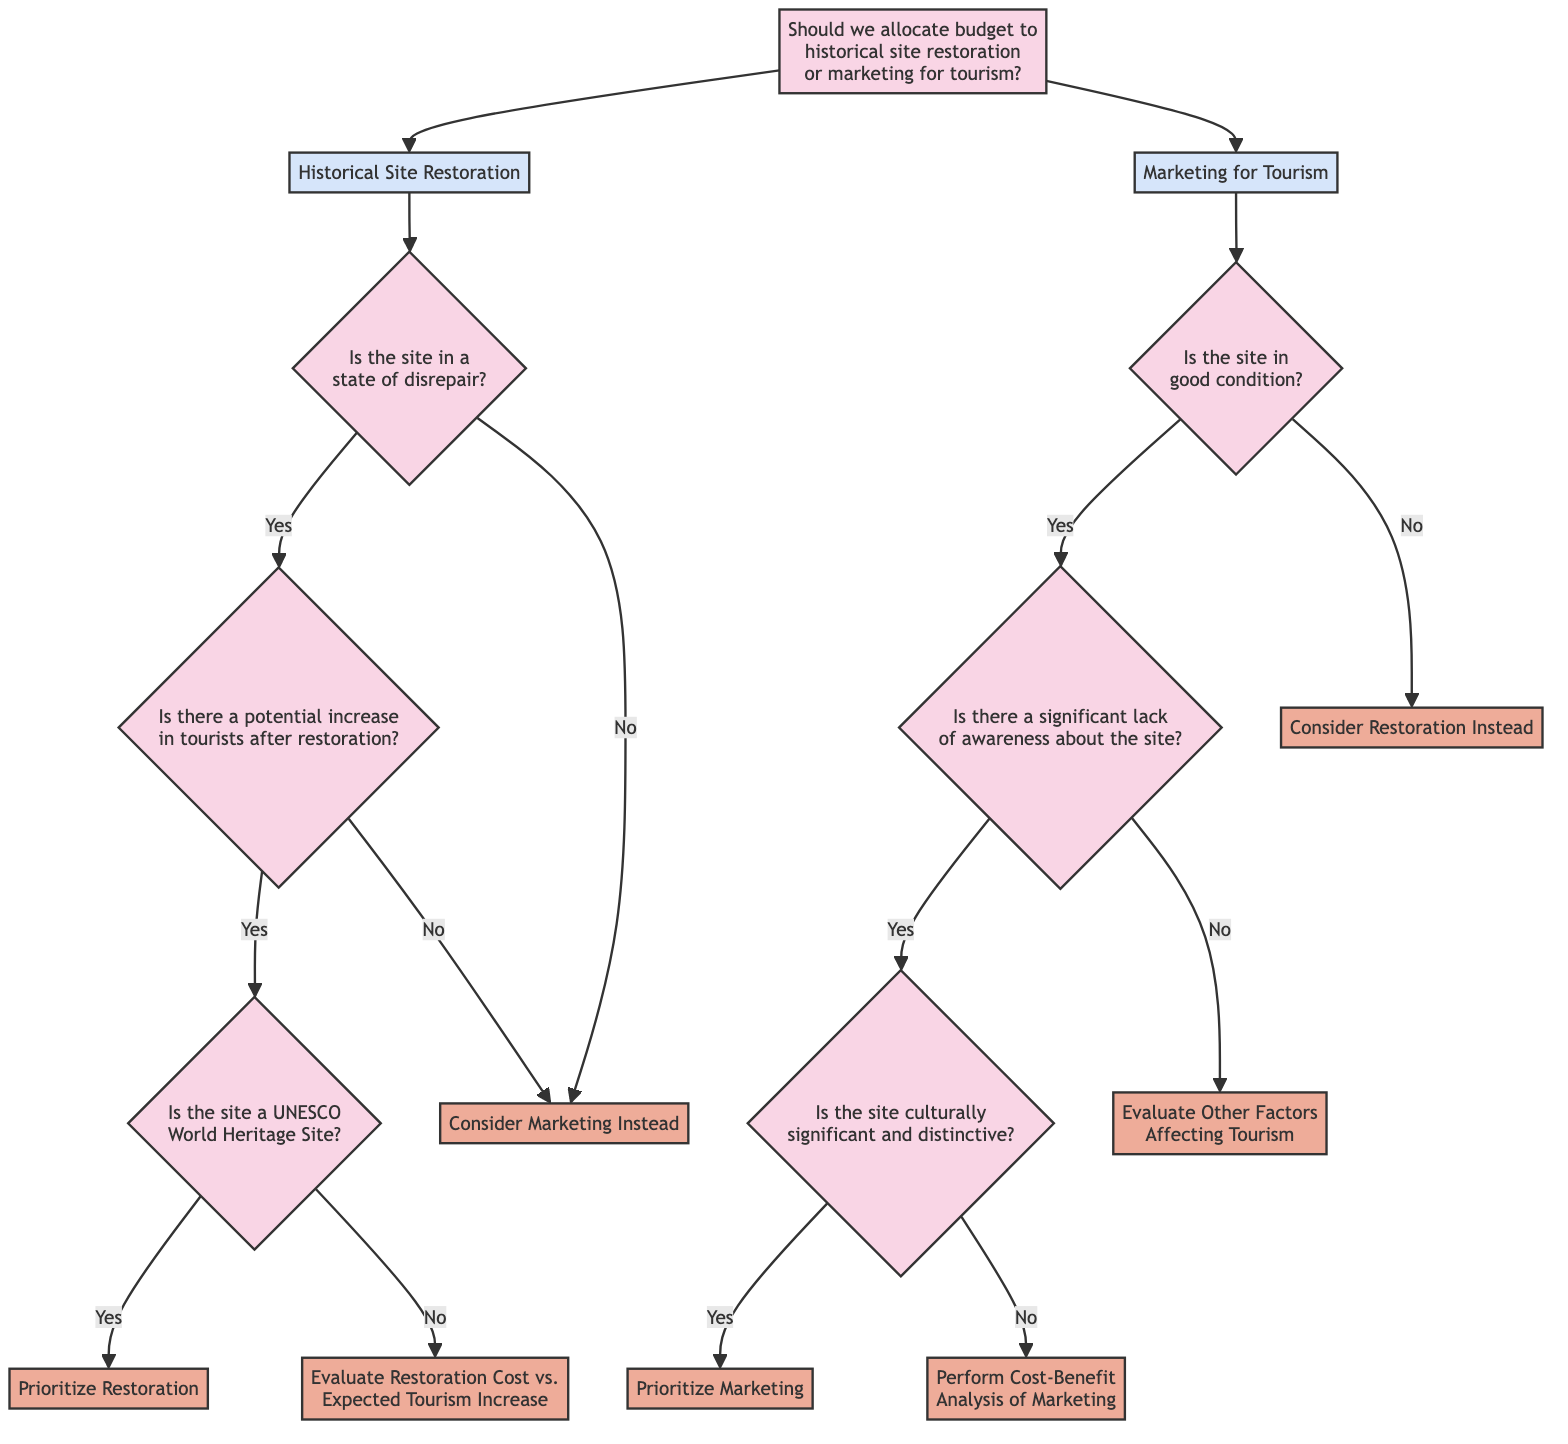What is the first decision to be made according to the diagram? The first decision presented in the diagram is whether to allocate budget to historical site restoration or marketing for tourism. This is the initial question represented at the top node of the decision tree.
Answer: historical site restoration or marketing for tourism How many options are available under historical site restoration? There are two main options under historical site restoration after deciding it: whether the site is in a state of disrepair (Yes or No). This branching shows two possible paths depending on the condition of the site.
Answer: 2 What action is prompted if the site is a UNESCO World Heritage Site? If the site is identified as a UNESCO World Heritage Site after determining that restoration would lead to increased tourism, the action specified is to prioritize restoration. This is a direct consequence of the subsequent branching of questions in the tree.
Answer: Prioritize Restoration If the site is in good condition, what is the next question asked? The next question asked if the site is in good condition is whether there is a significant lack of awareness about the site. This follows the path if the condition is deemed beneficial for tourism.
Answer: Is there a significant lack of awareness about the site? What is the action taken if the site is not historically significant? If the site is shown to lack cultural significance and distinctiveness after checking for awareness, the action recommended is to perform a cost-benefit analysis of marketing. This is indicated after evaluating the site's characteristics.
Answer: Perform Cost-Benefit Analysis of Marketing What happens if the site is in disrepair but there is no expected increase in tourists post-restoration? If the site is in disrepair, and it has been determined that there will be no potential increase in tourists after restoration, the action taken is to consider marketing instead. This directly follows from the flow of the decision tree when evaluating restoration outcomes.
Answer: Consider Marketing Instead How many end actions are there in total in the diagram? The diagram shows a total of five unique end actions: prior to restoration, evaluate restoration cost, consider marketing, prioritize marketing, and perform a cost-benefit analysis. Each action signifies a final decision point in the decision-making process.
Answer: 5 What is the main criterion for prioritizing marketing? The main criterion for prioritizing marketing is whether the site is culturally significant and distinctive after confirming there is a lack of awareness about the site. This decision hinges on distinguishing characteristics of the site that may attract tourism.
Answer: Culturally significant and distinctive 